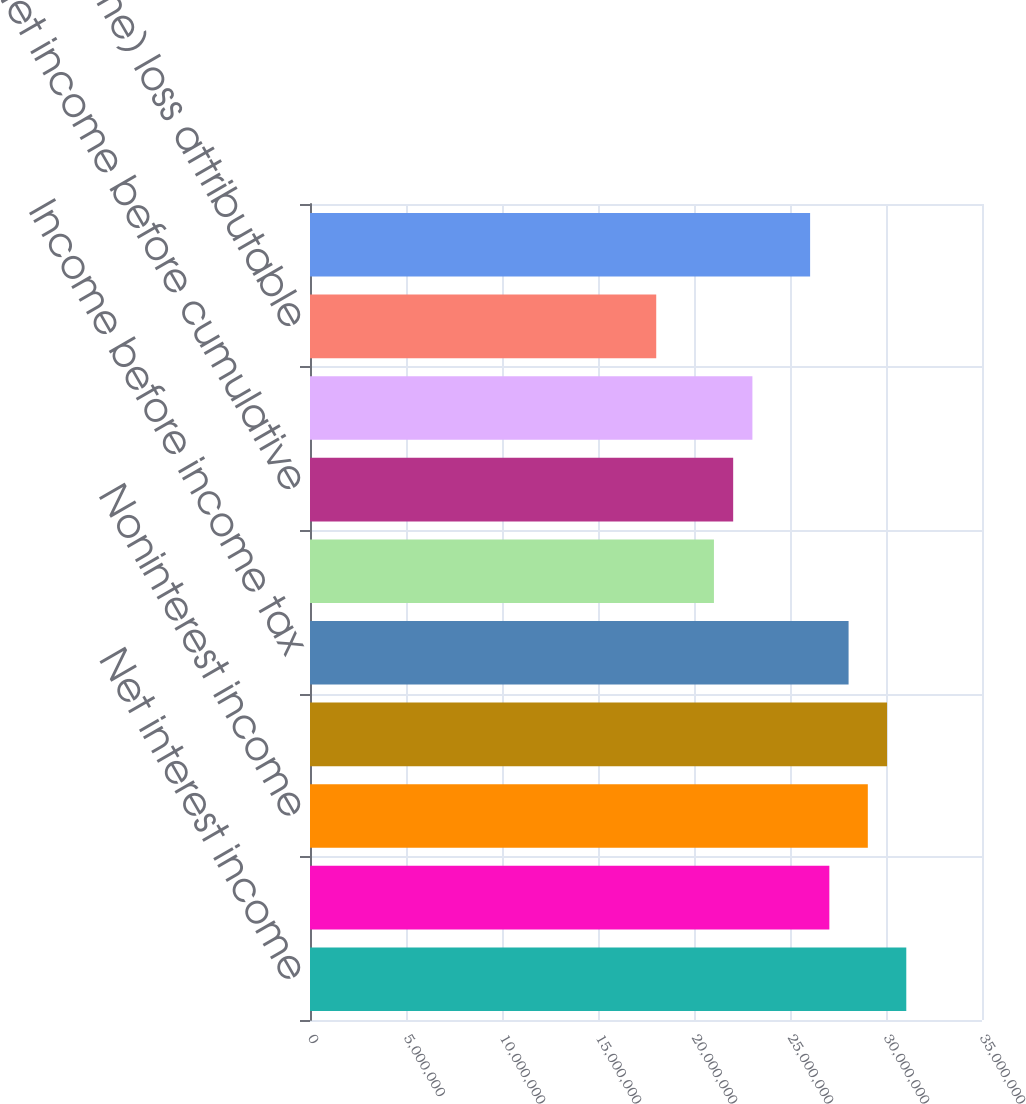<chart> <loc_0><loc_0><loc_500><loc_500><bar_chart><fcel>Net interest income<fcel>Provision for loan losses<fcel>Noninterest income<fcel>Noninterest expense excluding<fcel>Income before income tax<fcel>Income tax expense<fcel>Net income before cumulative<fcel>Net income before<fcel>Net (income) loss attributable<fcel>Net income attributable to<nl><fcel>3.10567e+07<fcel>2.70494e+07<fcel>2.9053e+07<fcel>3.00548e+07<fcel>2.80512e+07<fcel>2.10384e+07<fcel>2.20402e+07<fcel>2.3042e+07<fcel>1.80329e+07<fcel>2.60475e+07<nl></chart> 